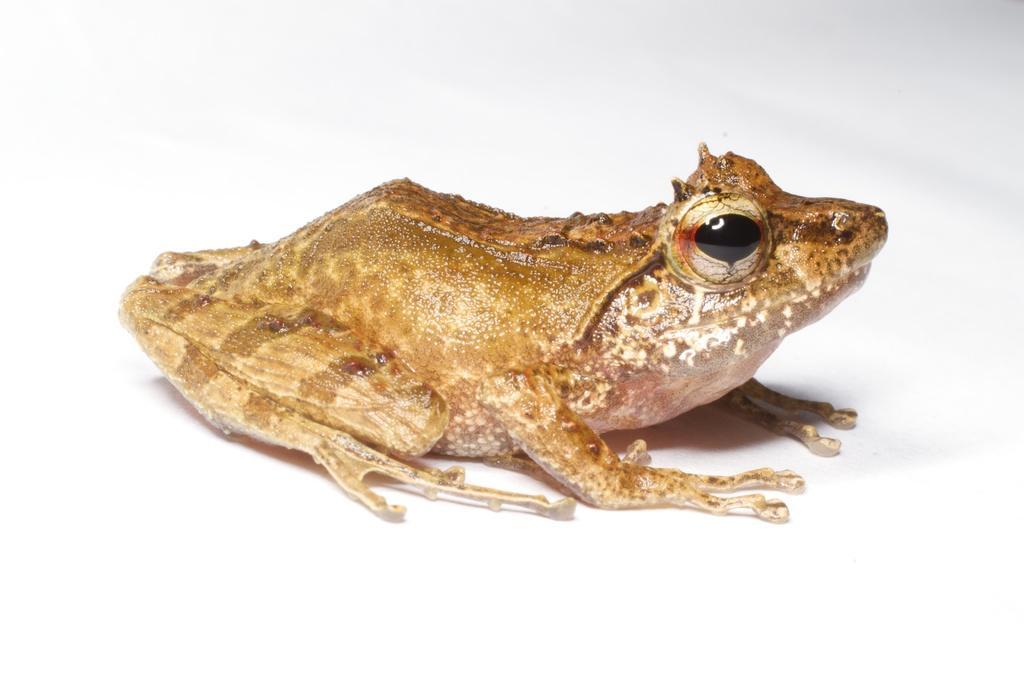How would you summarize this image in a sentence or two? In this picture I can see a frog on an object. 